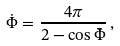<formula> <loc_0><loc_0><loc_500><loc_500>\dot { \Phi } = \frac { 4 \pi } { 2 - \cos \bar { \Phi } } \, ,</formula> 